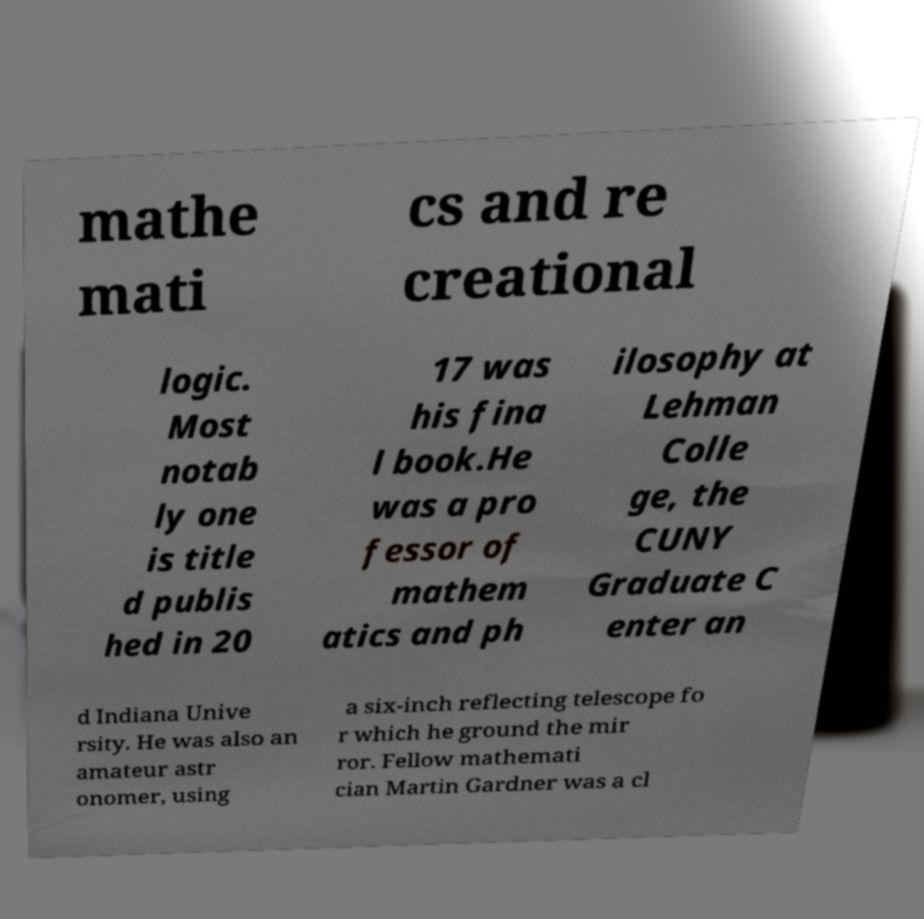For documentation purposes, I need the text within this image transcribed. Could you provide that? mathe mati cs and re creational logic. Most notab ly one is title d publis hed in 20 17 was his fina l book.He was a pro fessor of mathem atics and ph ilosophy at Lehman Colle ge, the CUNY Graduate C enter an d Indiana Unive rsity. He was also an amateur astr onomer, using a six-inch reflecting telescope fo r which he ground the mir ror. Fellow mathemati cian Martin Gardner was a cl 